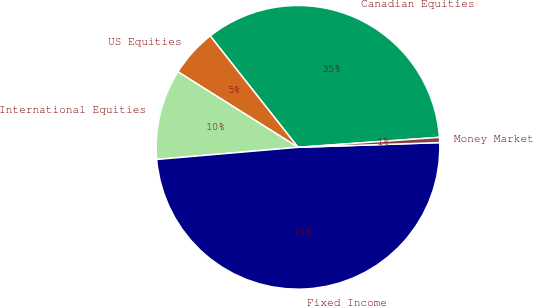<chart> <loc_0><loc_0><loc_500><loc_500><pie_chart><fcel>Canadian Equities<fcel>US Equities<fcel>International Equities<fcel>Fixed Income<fcel>Money Market<nl><fcel>34.5%<fcel>5.44%<fcel>10.3%<fcel>49.16%<fcel>0.59%<nl></chart> 